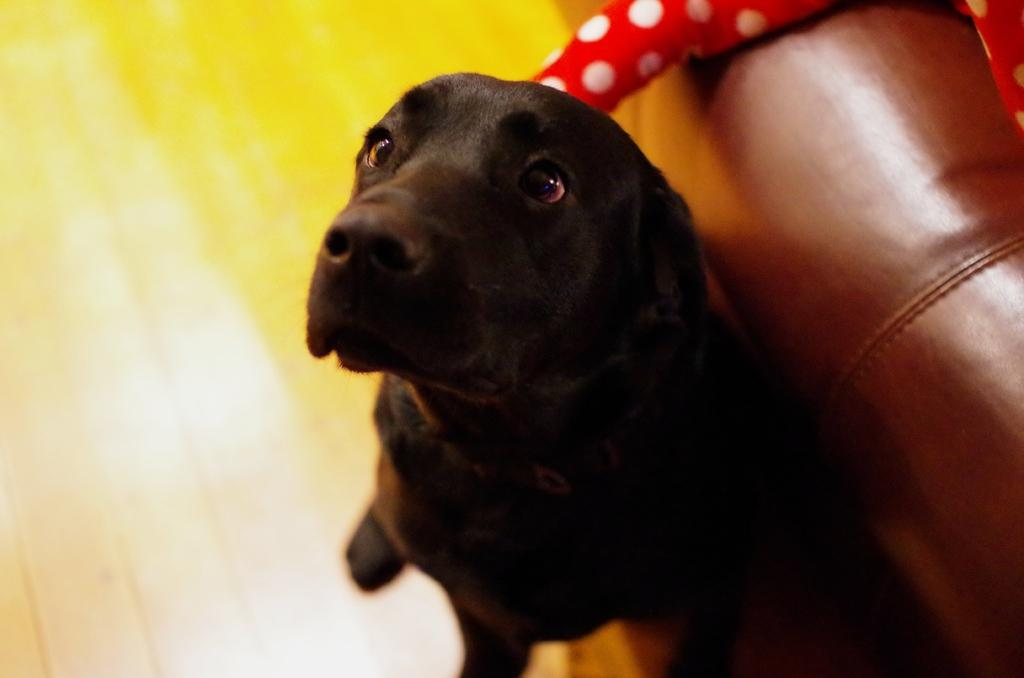What type of animal is in the image? There is a dog in the image. What color is the dog? The dog is black in color. What is the dog standing on in the image? The dog is on a yellow and brown colored surface. What type of furniture is in the image? There is a brown couch in the image. What is the color and pattern of the object next to the dog? There is a red and white colored object in the image. How many snails can be seen crawling on the dog in the image? There are no snails visible in the image. 